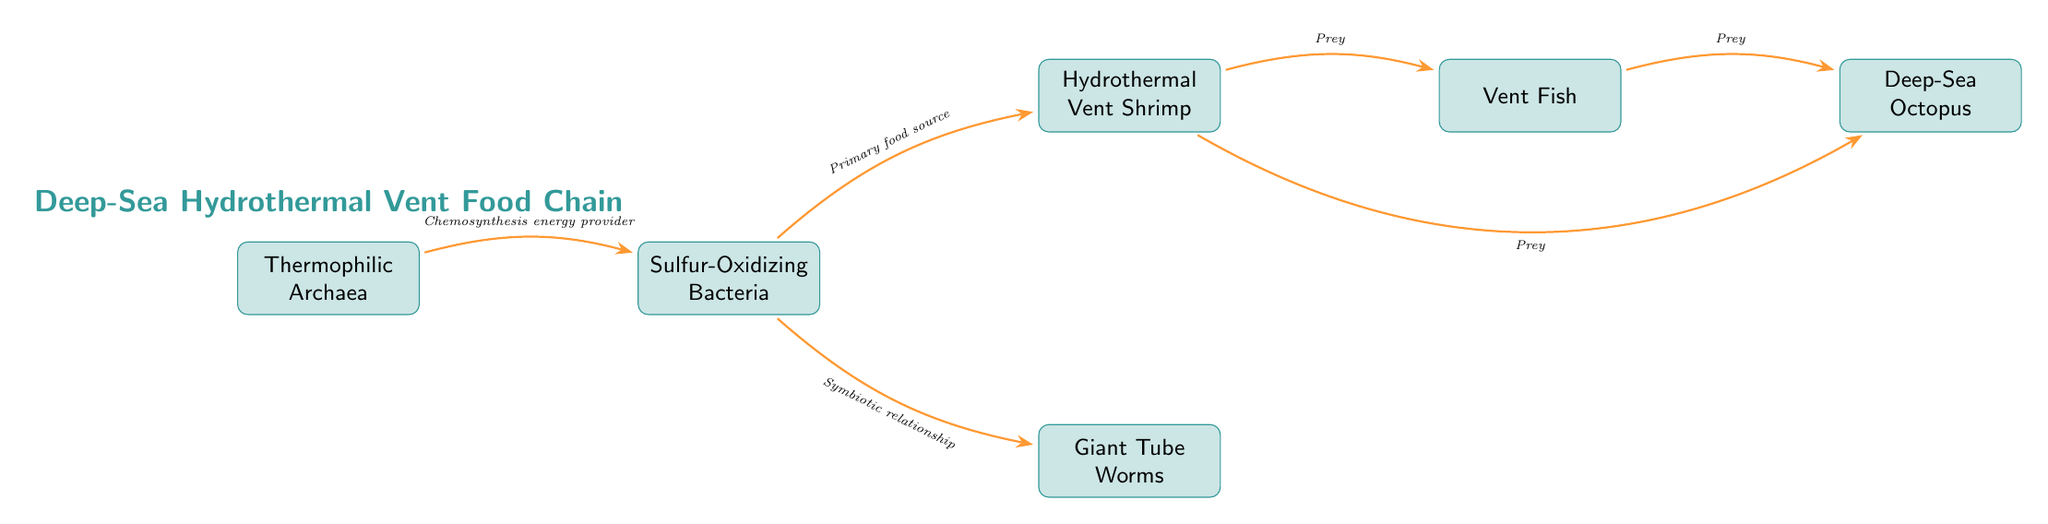What is the energy source for Sulfur-Oxidizing Bacteria? The diagram indicates that Thermophilic Archaea provide energy through chemosynthesis, which is their primary food source.
Answer: Chemosynthesis energy provider Which organism directly consumes Sulfur-Oxidizing Bacteria? The diagram shows that Hydrothermal Vent Shrimp obtain their food directly from Sulfur-Oxidizing Bacteria, represented by the flow from the bacteria to the shrimp.
Answer: Hydrothermal Vent Shrimp How many primary organisms are involved in the food chain? There are six organisms listed in the diagram: Thermophilic Archaea, Sulfur-Oxidizing Bacteria, Hydrothermal Vent Shrimp, Vent Fish, Giant Tube Worms, and Deep-Sea Octopus.
Answer: Six What type of relationship do Giant Tube Worms have with Sulfur-Oxidizing Bacteria? The diagram illustrates that the relationship is symbiotic, meaning both organisms benefit from the interaction as indicated by the flow arrow between them.
Answer: Symbiotic relationship Which organism is at the top of the food chain? The flow direction in the diagram indicates that the Deep-Sea Octopus is at the top, as it preys on both Vent Fish and Hydrothermal Vent Shrimp.
Answer: Deep-Sea Octopus What is the role of Hydrothermal Vent Shrimp in this food chain? The diagram shows that Hydrothermal Vent Shrimp acts as a predator, feeding on Sulfur-Oxidizing Bacteria and serving as prey for Vent Fish.
Answer: Predator How many direct prey relationships does the Vent Fish have in this food chain? From the diagram, the Vent Fish preys on Hydrothermal Vent Shrimp and is in a predator relationship but does not appear to have other direct prey shown. Therefore, it has one direct prey relationship.
Answer: One What type of flow is represented between the Thermophilic Archaea and Sulfur-Oxidizing Bacteria? The diagram specifies that the flow is described as an energy provision relationship, indicating that Thermophilic Archaea provide energy for the Sulfur-Oxidizing Bacteria through chemosynthesis.
Answer: Chemosynthesis energy provider 